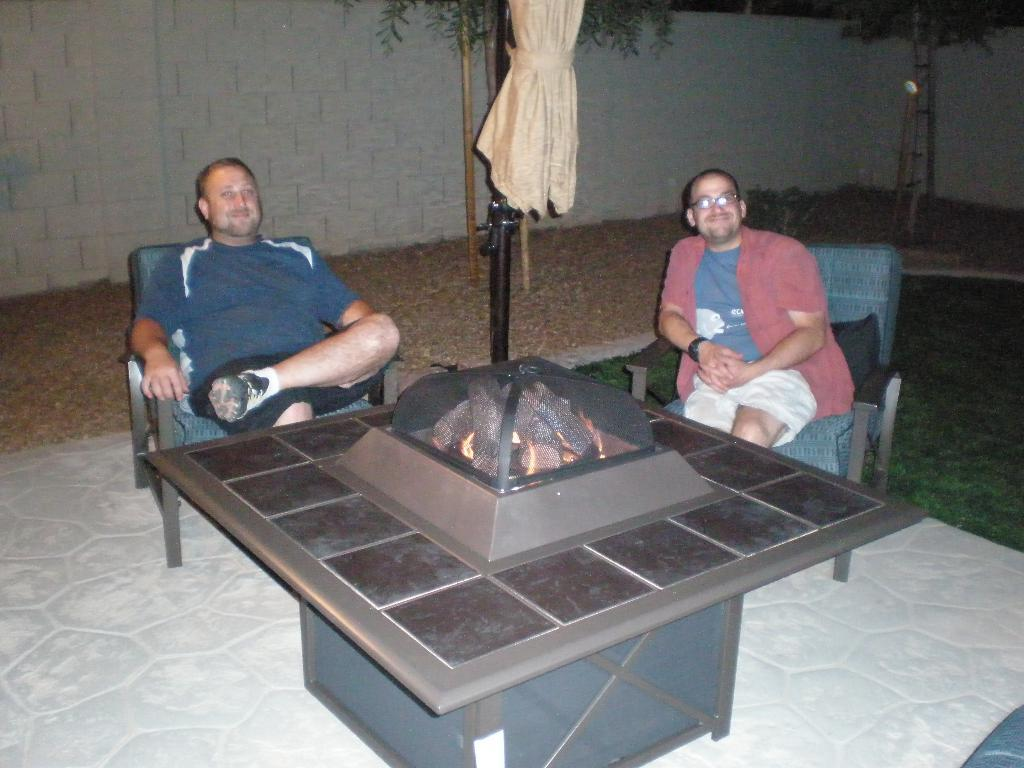How many people are sitting in the image? There are two persons sitting on chairs in the image. What is present on which they are sitting? There is a table in the image. What can be seen beneath the table and chairs? The floor is visible in the image. What type of natural environment is depicted in the image? There is grass, trees, and a wall in the image, suggesting a natural setting. What side of the queen is shown in the image? There is no queen present in the image; it features two persons sitting on chairs. What historical event is depicted in the image? There is no historical event depicted in the image; it shows a scene with two persons sitting on chairs, a table, and a natural setting. 